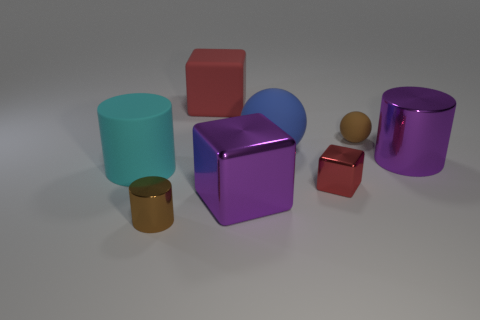How many blocks are there?
Offer a very short reply. 3. What number of objects are big blue metal cylinders or large red matte objects?
Your answer should be compact. 1. There is a metallic cylinder on the left side of the large block behind the large cyan cylinder; how many brown things are behind it?
Provide a short and direct response. 1. Are there any other things of the same color as the small block?
Provide a short and direct response. Yes. Is the color of the rubber ball that is left of the small brown matte ball the same as the large thing that is on the right side of the blue matte sphere?
Make the answer very short. No. Is the number of purple metallic things in front of the small red cube greater than the number of large purple metallic blocks that are right of the large matte ball?
Your answer should be compact. Yes. What material is the tiny brown ball?
Your answer should be very brief. Rubber. What shape is the small brown object that is behind the shiny cylinder that is in front of the purple object left of the small red metallic block?
Provide a succinct answer. Sphere. What number of other things are the same material as the large blue object?
Provide a succinct answer. 3. Does the red block that is in front of the big blue sphere have the same material as the big cylinder that is to the left of the blue thing?
Ensure brevity in your answer.  No. 